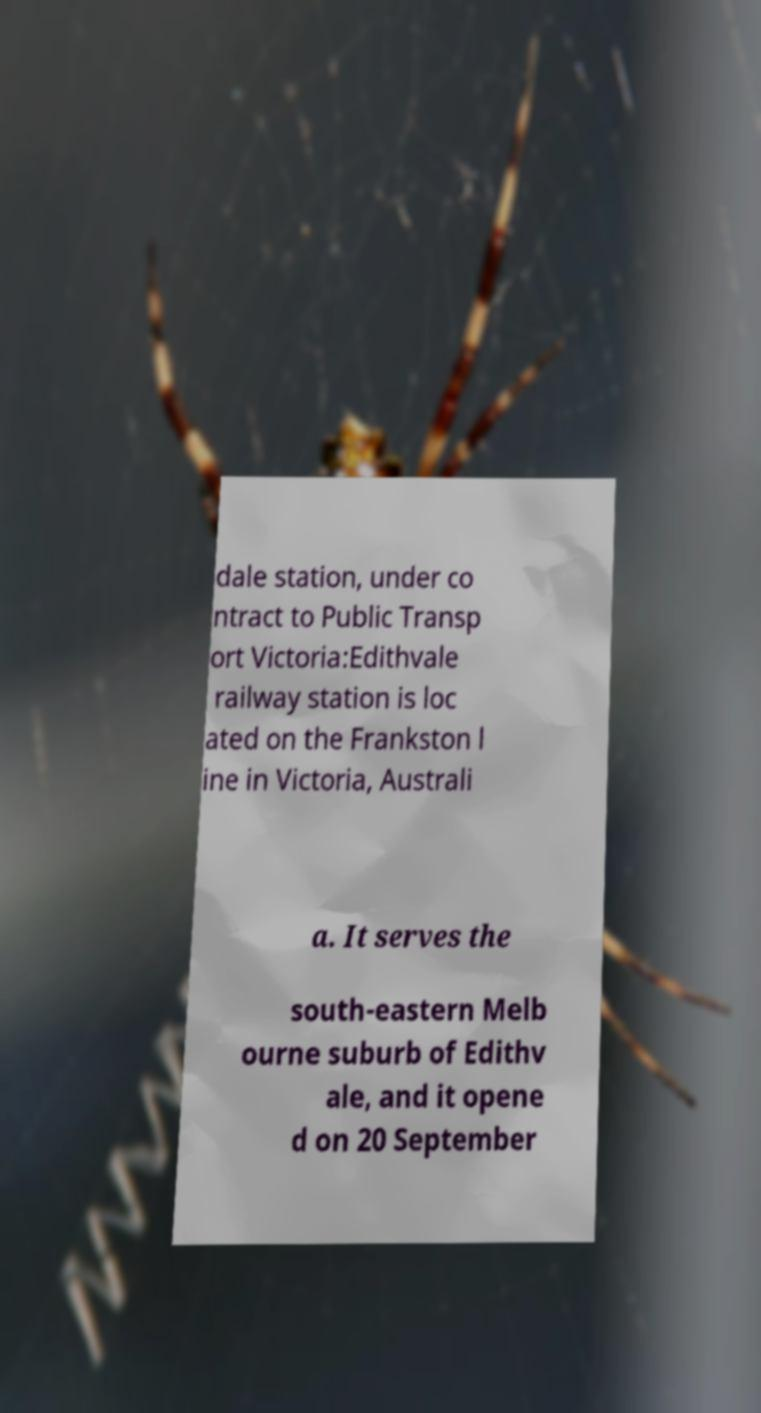Can you accurately transcribe the text from the provided image for me? dale station, under co ntract to Public Transp ort Victoria:Edithvale railway station is loc ated on the Frankston l ine in Victoria, Australi a. It serves the south-eastern Melb ourne suburb of Edithv ale, and it opene d on 20 September 